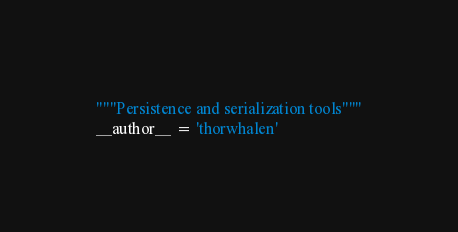Convert code to text. <code><loc_0><loc_0><loc_500><loc_500><_Python_>"""Persistence and serialization tools"""
__author__ = 'thorwhalen'
</code> 